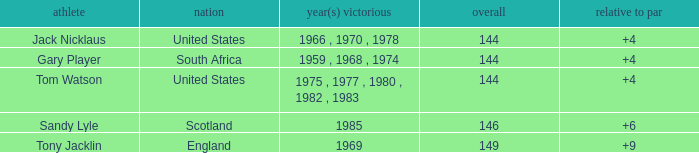What was England's total? 149.0. 